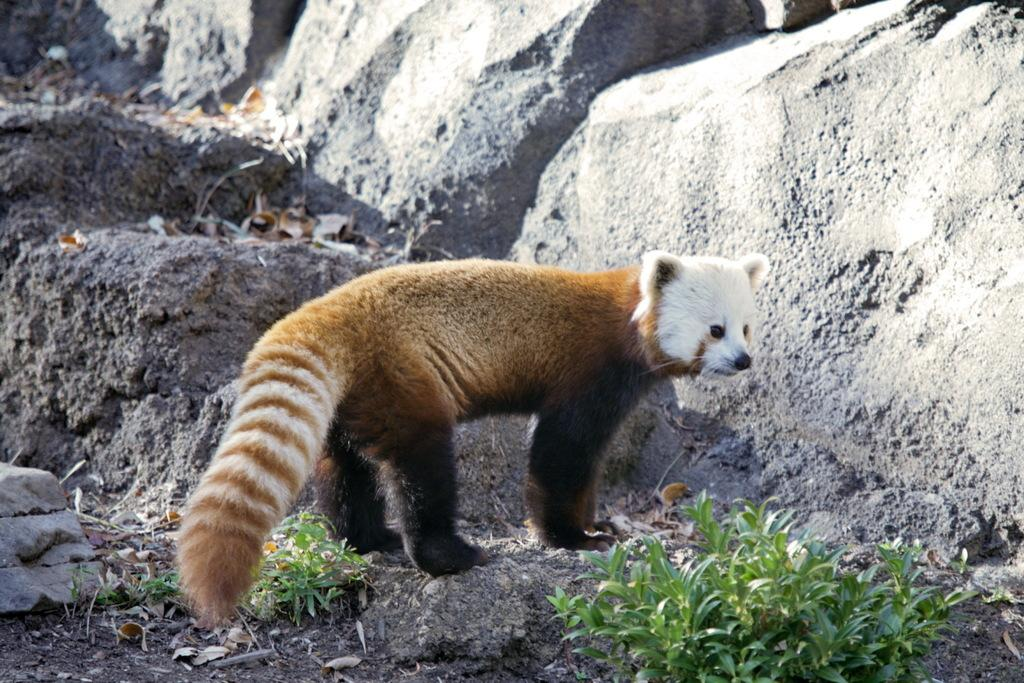What type of animal is in the image? There is a red panda in the image. What can be seen at the bottom of the image? There are plants at the bottom of the image. What is visible in the background of the image? There are rocks visible in the background of the image. How many clocks can be seen hanging on the rocks in the image? There are no clocks visible in the image; it only features a red panda, plants, and rocks. 